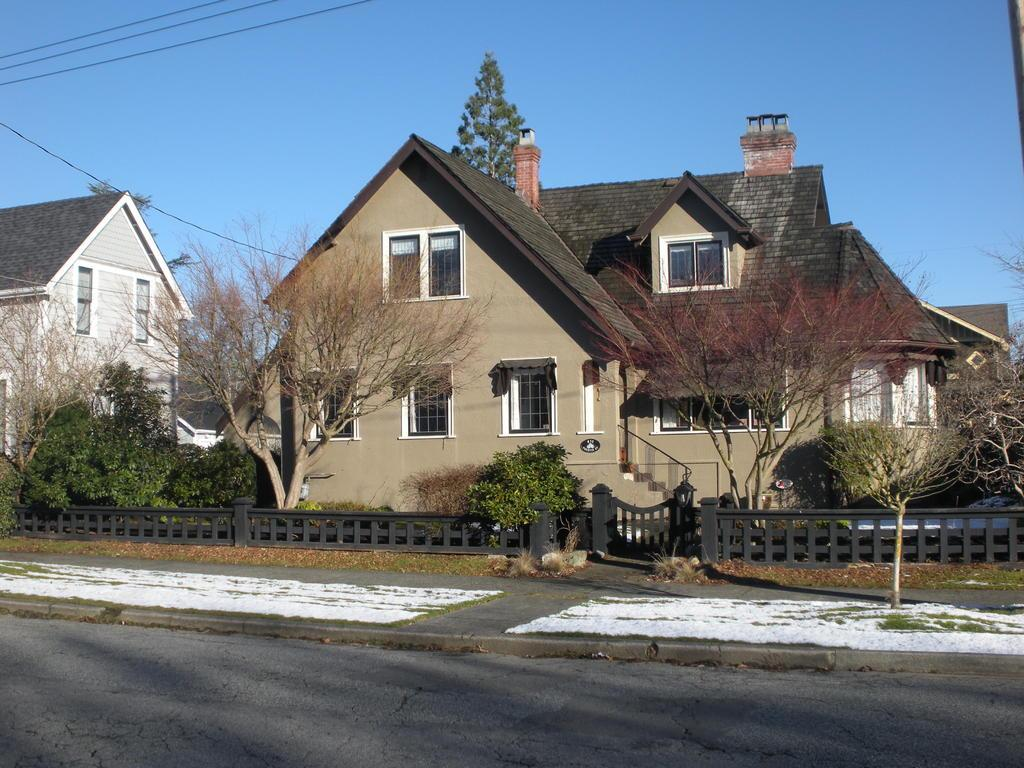What type of structures can be seen in the image? There are buildings in the image. What other natural elements are present in the image? There are trees in the image. Is there any barrier or enclosure visible in the image? Yes, there is a fence in the image. What color is the sky in the image? The sky is blue in the image. What riddle can be solved by looking at the image? There is no riddle present in the image; it simply depicts buildings, trees, a fence, and a blue sky. Can you see any waves in the image? There are no waves present in the image, as it does not depict a body of water or any wave-like features. 